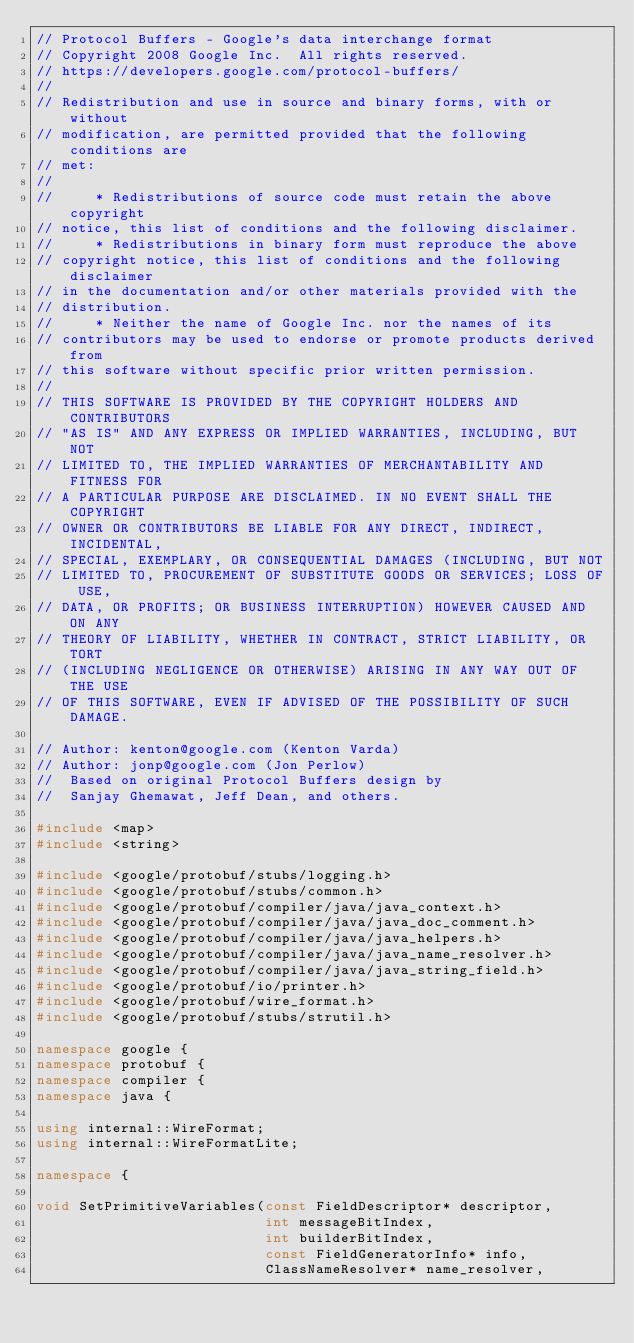<code> <loc_0><loc_0><loc_500><loc_500><_C++_>// Protocol Buffers - Google's data interchange format
// Copyright 2008 Google Inc.  All rights reserved.
// https://developers.google.com/protocol-buffers/
//
// Redistribution and use in source and binary forms, with or without
// modification, are permitted provided that the following conditions are
// met:
//
//     * Redistributions of source code must retain the above copyright
// notice, this list of conditions and the following disclaimer.
//     * Redistributions in binary form must reproduce the above
// copyright notice, this list of conditions and the following disclaimer
// in the documentation and/or other materials provided with the
// distribution.
//     * Neither the name of Google Inc. nor the names of its
// contributors may be used to endorse or promote products derived from
// this software without specific prior written permission.
//
// THIS SOFTWARE IS PROVIDED BY THE COPYRIGHT HOLDERS AND CONTRIBUTORS
// "AS IS" AND ANY EXPRESS OR IMPLIED WARRANTIES, INCLUDING, BUT NOT
// LIMITED TO, THE IMPLIED WARRANTIES OF MERCHANTABILITY AND FITNESS FOR
// A PARTICULAR PURPOSE ARE DISCLAIMED. IN NO EVENT SHALL THE COPYRIGHT
// OWNER OR CONTRIBUTORS BE LIABLE FOR ANY DIRECT, INDIRECT, INCIDENTAL,
// SPECIAL, EXEMPLARY, OR CONSEQUENTIAL DAMAGES (INCLUDING, BUT NOT
// LIMITED TO, PROCUREMENT OF SUBSTITUTE GOODS OR SERVICES; LOSS OF USE,
// DATA, OR PROFITS; OR BUSINESS INTERRUPTION) HOWEVER CAUSED AND ON ANY
// THEORY OF LIABILITY, WHETHER IN CONTRACT, STRICT LIABILITY, OR TORT
// (INCLUDING NEGLIGENCE OR OTHERWISE) ARISING IN ANY WAY OUT OF THE USE
// OF THIS SOFTWARE, EVEN IF ADVISED OF THE POSSIBILITY OF SUCH DAMAGE.

// Author: kenton@google.com (Kenton Varda)
// Author: jonp@google.com (Jon Perlow)
//  Based on original Protocol Buffers design by
//  Sanjay Ghemawat, Jeff Dean, and others.

#include <map>
#include <string>

#include <google/protobuf/stubs/logging.h>
#include <google/protobuf/stubs/common.h>
#include <google/protobuf/compiler/java/java_context.h>
#include <google/protobuf/compiler/java/java_doc_comment.h>
#include <google/protobuf/compiler/java/java_helpers.h>
#include <google/protobuf/compiler/java/java_name_resolver.h>
#include <google/protobuf/compiler/java/java_string_field.h>
#include <google/protobuf/io/printer.h>
#include <google/protobuf/wire_format.h>
#include <google/protobuf/stubs/strutil.h>

namespace google {
namespace protobuf {
namespace compiler {
namespace java {

using internal::WireFormat;
using internal::WireFormatLite;

namespace {

void SetPrimitiveVariables(const FieldDescriptor* descriptor,
                           int messageBitIndex,
                           int builderBitIndex,
                           const FieldGeneratorInfo* info,
                           ClassNameResolver* name_resolver,</code> 